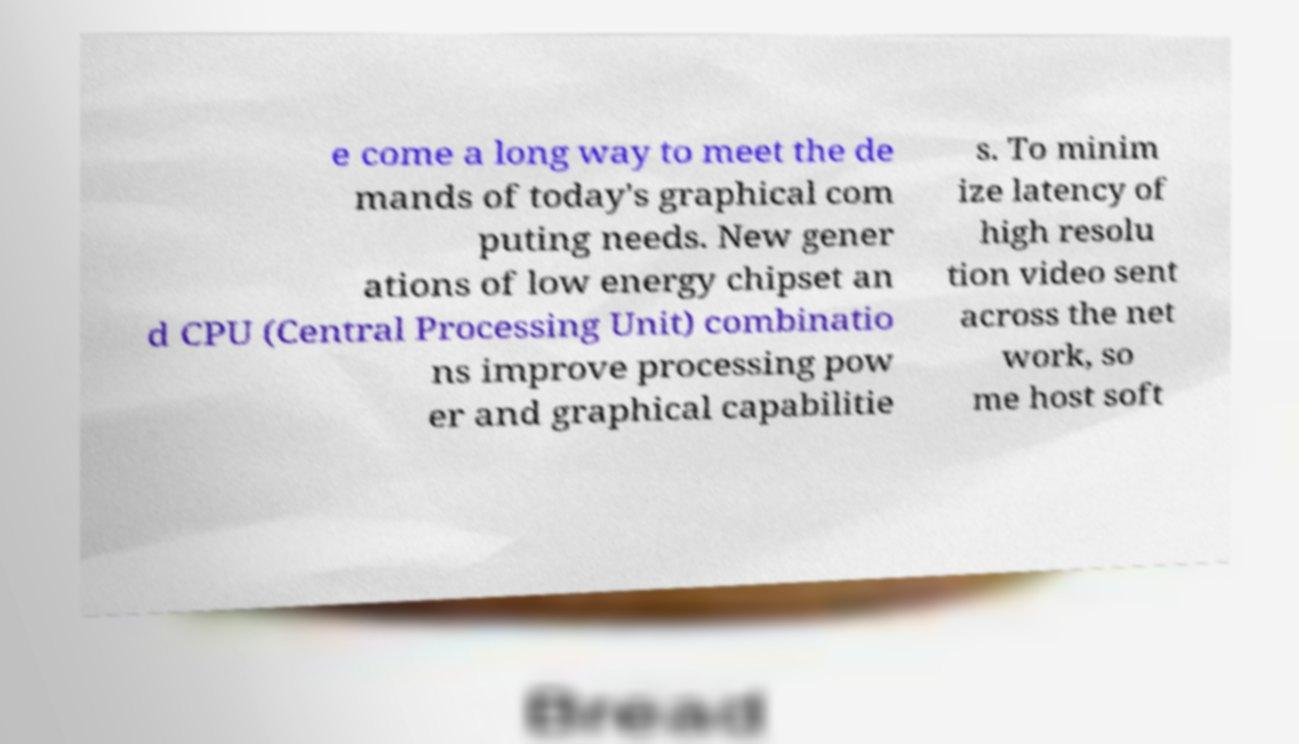Please identify and transcribe the text found in this image. e come a long way to meet the de mands of today's graphical com puting needs. New gener ations of low energy chipset an d CPU (Central Processing Unit) combinatio ns improve processing pow er and graphical capabilitie s. To minim ize latency of high resolu tion video sent across the net work, so me host soft 